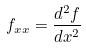Convert formula to latex. <formula><loc_0><loc_0><loc_500><loc_500>f _ { x x } = \frac { d ^ { 2 } f } { d x ^ { 2 } }</formula> 